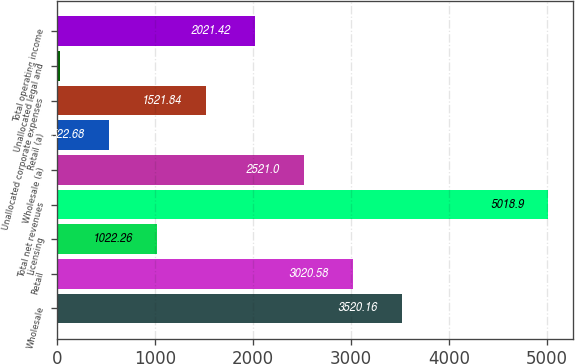Convert chart to OTSL. <chart><loc_0><loc_0><loc_500><loc_500><bar_chart><fcel>Wholesale<fcel>Retail<fcel>Licensing<fcel>Total net revenues<fcel>Wholesale (a)<fcel>Retail (a)<fcel>Unallocated corporate expenses<fcel>Unallocated legal and<fcel>Total operating income<nl><fcel>3520.16<fcel>3020.58<fcel>1022.26<fcel>5018.9<fcel>2521<fcel>522.68<fcel>1521.84<fcel>23.1<fcel>2021.42<nl></chart> 